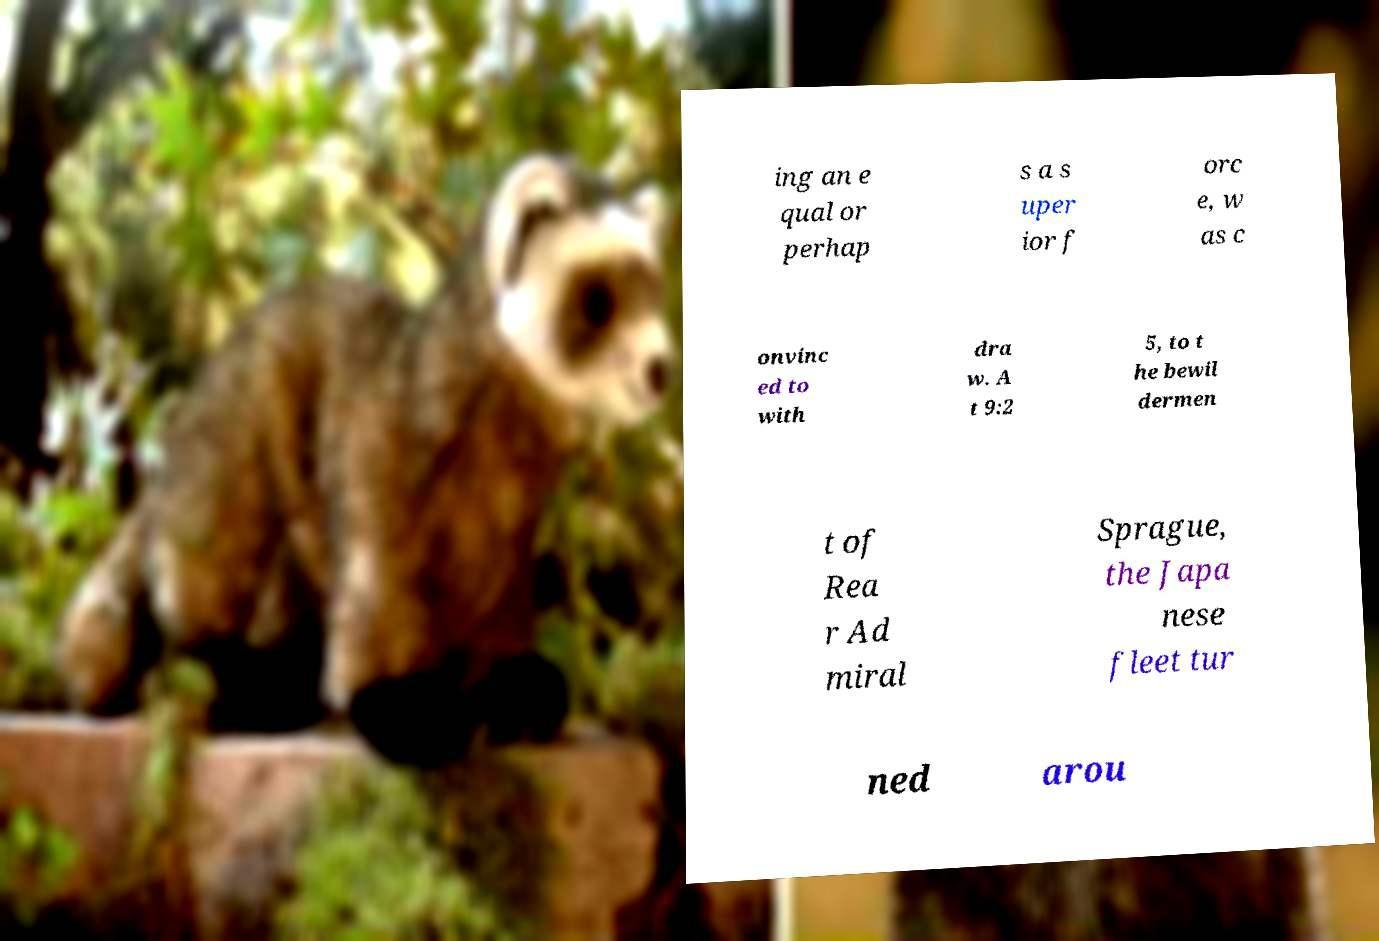Please identify and transcribe the text found in this image. ing an e qual or perhap s a s uper ior f orc e, w as c onvinc ed to with dra w. A t 9:2 5, to t he bewil dermen t of Rea r Ad miral Sprague, the Japa nese fleet tur ned arou 